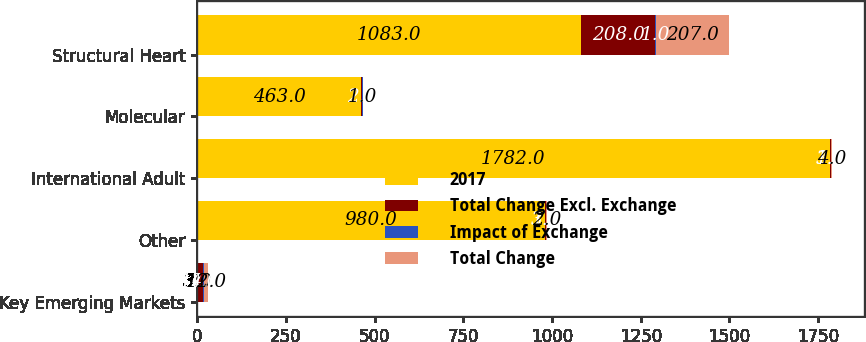Convert chart. <chart><loc_0><loc_0><loc_500><loc_500><stacked_bar_chart><ecel><fcel>Key Emerging Markets<fcel>Other<fcel>International Adult<fcel>Molecular<fcel>Structural Heart<nl><fcel>2017<fcel>3<fcel>980<fcel>1782<fcel>463<fcel>1083<nl><fcel>Total Change Excl. Exchange<fcel>14<fcel>3<fcel>3<fcel>2<fcel>208<nl><fcel>Impact of Exchange<fcel>2<fcel>1<fcel>1<fcel>1<fcel>1<nl><fcel>Total Change<fcel>12<fcel>2<fcel>4<fcel>1<fcel>207<nl></chart> 